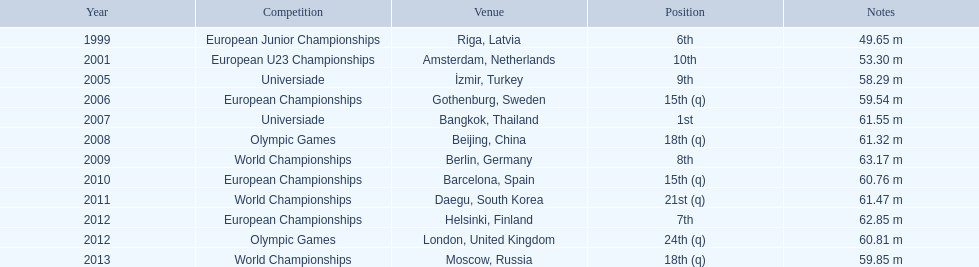What were the distances of mayer's throws? 49.65 m, 53.30 m, 58.29 m, 59.54 m, 61.55 m, 61.32 m, 63.17 m, 60.76 m, 61.47 m, 62.85 m, 60.81 m, 59.85 m. Which of these went the farthest? 63.17 m. 